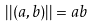<formula> <loc_0><loc_0><loc_500><loc_500>| | ( a , b ) | | = a b</formula> 